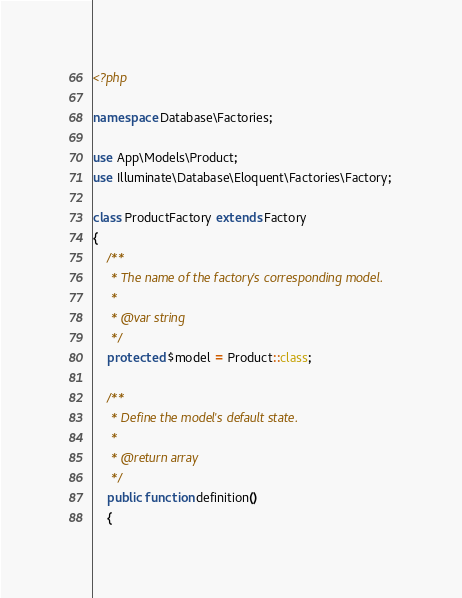<code> <loc_0><loc_0><loc_500><loc_500><_PHP_><?php

namespace Database\Factories;

use App\Models\Product;
use Illuminate\Database\Eloquent\Factories\Factory;

class ProductFactory extends Factory
{
    /**
     * The name of the factory's corresponding model.
     *
     * @var string
     */
    protected $model = Product::class;

    /**
     * Define the model's default state.
     *
     * @return array
     */
    public function definition()
    {</code> 